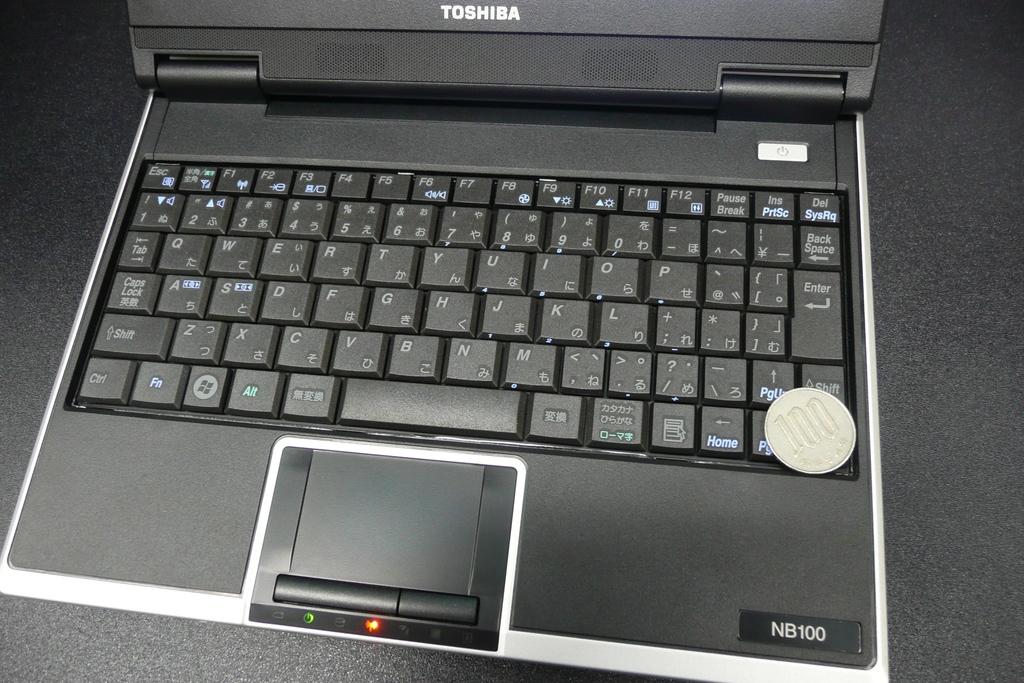What brand is this laptop?
Make the answer very short. Toshiba. Is this a nb100?
Offer a very short reply. Yes. 